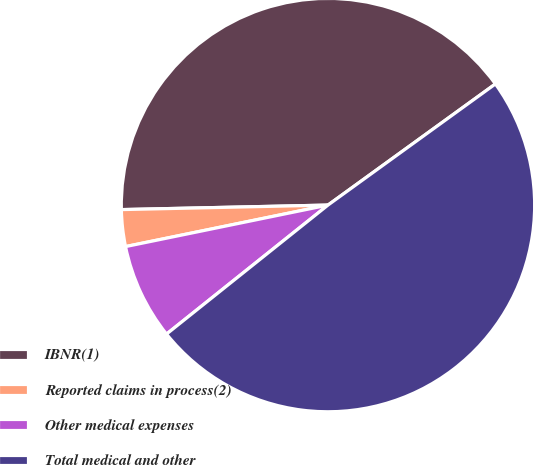Convert chart. <chart><loc_0><loc_0><loc_500><loc_500><pie_chart><fcel>IBNR(1)<fcel>Reported claims in process(2)<fcel>Other medical expenses<fcel>Total medical and other<nl><fcel>40.38%<fcel>2.87%<fcel>7.51%<fcel>49.24%<nl></chart> 